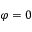Convert formula to latex. <formula><loc_0><loc_0><loc_500><loc_500>\varphi = 0</formula> 